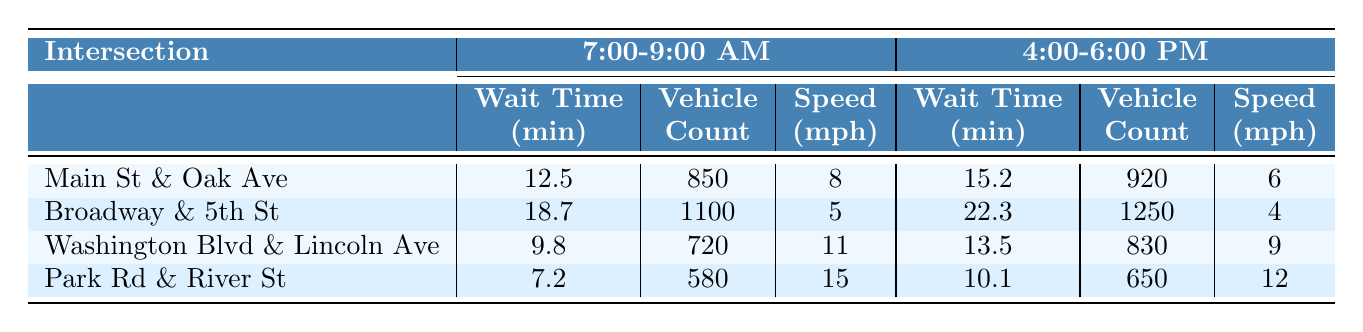What is the average wait time at Broadway & 5th St during the evening peak hours? From the table, the average wait time at Broadway & 5th St during the evening peak hours (4:00-6:00 PM) is 22.3 minutes.
Answer: 22.3 minutes Which intersection had the highest average vehicle count during the morning peak hours? By examining the table, Broadway & 5th St had the highest average vehicle count during the morning peak hours at 1100 vehicles.
Answer: Broadway & 5th St What is the difference in average wait time between the morning and evening peak hours at Main St & Oak Ave? The average wait time at Main St & Oak Ave is 12.5 minutes in the morning and 15.2 minutes in the evening. The difference is 15.2 - 12.5 = 2.7 minutes.
Answer: 2.7 minutes Which intersection has the highest average speed during the morning peak hours? Checking the table, Park Rd & River St has the highest average speed during the morning peak hours at 15 mph.
Answer: Park Rd & River St Is the average wait time greater than 15 minutes for the evening peak hours at any intersection? Yes, at Broadway & 5th St, the average wait time is 22.3 minutes, which is greater than 15 minutes.
Answer: Yes Calculate the average average wait time during the morning peak hours across all intersections. The average wait times for the morning peak hours are: 12.5 (Main St) + 18.7 (Broadway) + 9.8 (Washington) + 7.2 (Park Rd) = 48.2 minutes. Dividing by 4 intersections gives 48.2 / 4 = 12.05 minutes.
Answer: 12.05 minutes What is the average speed difference between the highest and lowest intersection speeds during the evening peak hours? The highest average speed during the evening is at Park Rd & River St at 12 mph, and the lowest is at Broadway & 5th St at 4 mph. The speed difference is 12 - 4 = 8 mph.
Answer: 8 mph 